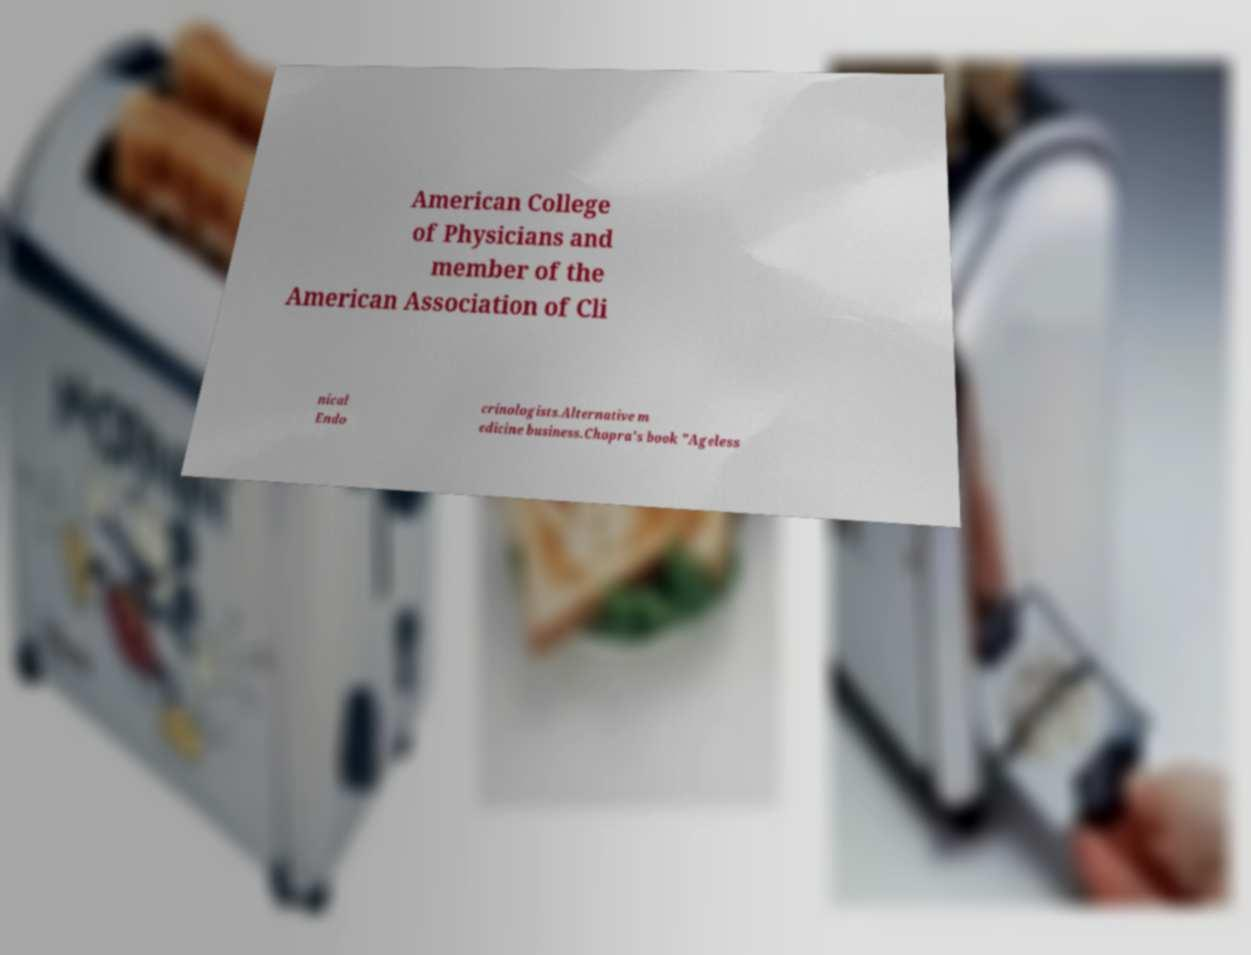For documentation purposes, I need the text within this image transcribed. Could you provide that? American College of Physicians and member of the American Association of Cli nical Endo crinologists.Alternative m edicine business.Chopra's book "Ageless 